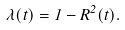<formula> <loc_0><loc_0><loc_500><loc_500>\lambda ( t ) = 1 - R ^ { 2 } ( t ) .</formula> 